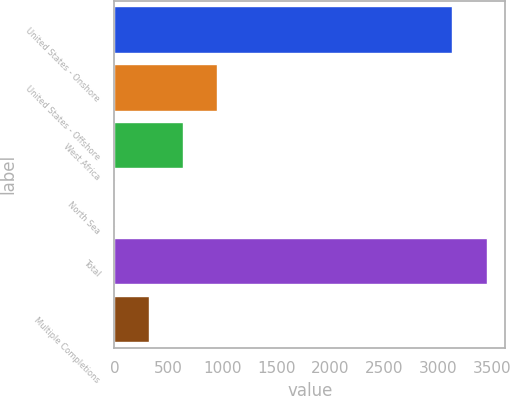<chart> <loc_0><loc_0><loc_500><loc_500><bar_chart><fcel>United States - Onshore<fcel>United States - Offshore<fcel>West Africa<fcel>North Sea<fcel>Total<fcel>Multiple Completions<nl><fcel>3134.5<fcel>948.28<fcel>632.42<fcel>0.7<fcel>3450.36<fcel>316.56<nl></chart> 